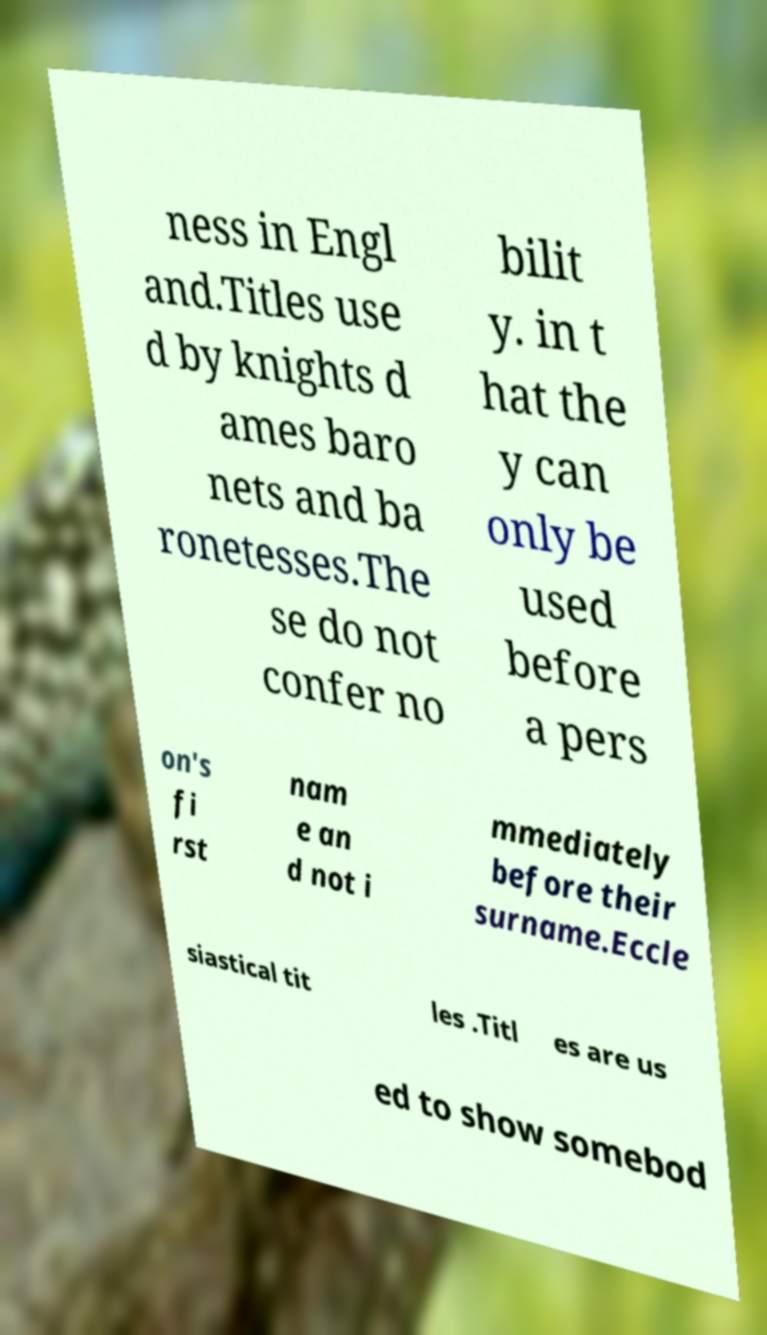There's text embedded in this image that I need extracted. Can you transcribe it verbatim? ness in Engl and.Titles use d by knights d ames baro nets and ba ronetesses.The se do not confer no bilit y. in t hat the y can only be used before a pers on's fi rst nam e an d not i mmediately before their surname.Eccle siastical tit les .Titl es are us ed to show somebod 